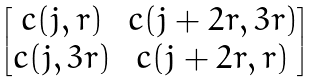<formula> <loc_0><loc_0><loc_500><loc_500>\begin{bmatrix} c ( j , r ) & c ( j + 2 r , 3 r ) \\ c ( j , 3 r ) & c ( j + 2 r , r ) \end{bmatrix}</formula> 